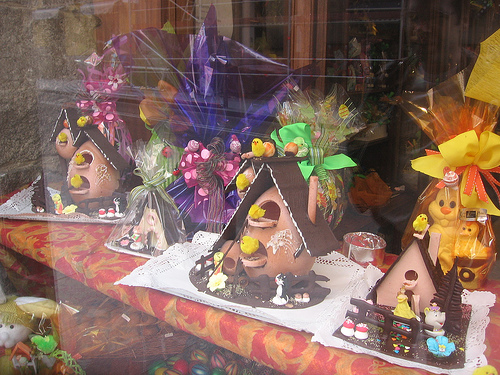<image>
Is there a wrapper on the chocolate house? No. The wrapper is not positioned on the chocolate house. They may be near each other, but the wrapper is not supported by or resting on top of the chocolate house. Is there a chick under the egg? No. The chick is not positioned under the egg. The vertical relationship between these objects is different. 